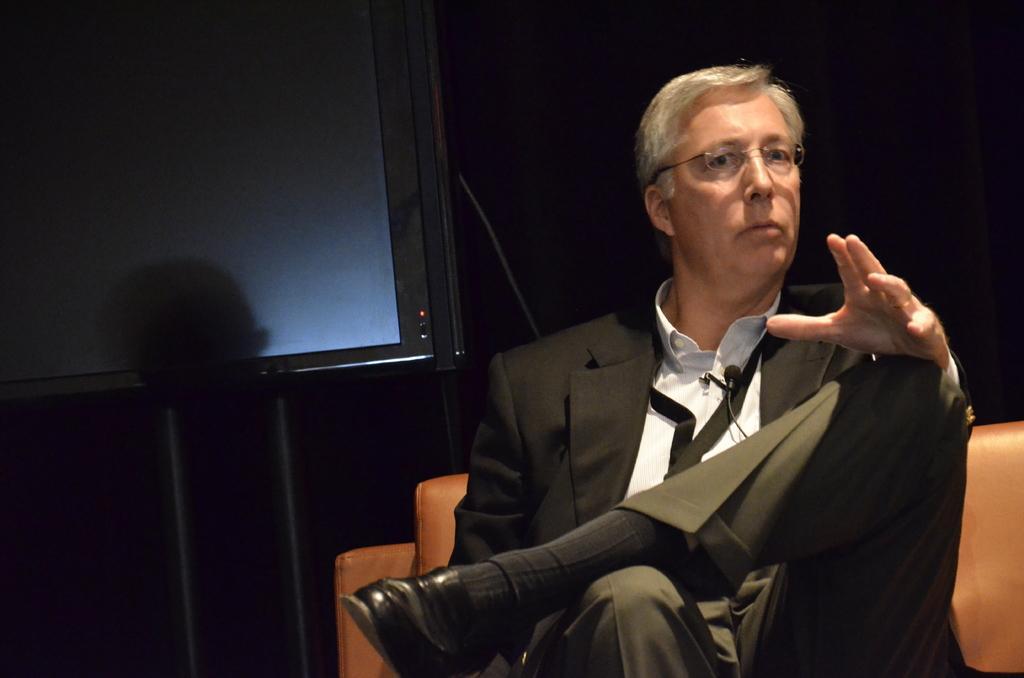Please provide a concise description of this image. Here in this picture we can see a person in black colored suit sitting on chair over there and he is wearing spectacles on him and behind him we can see a board present on the stand over there. 